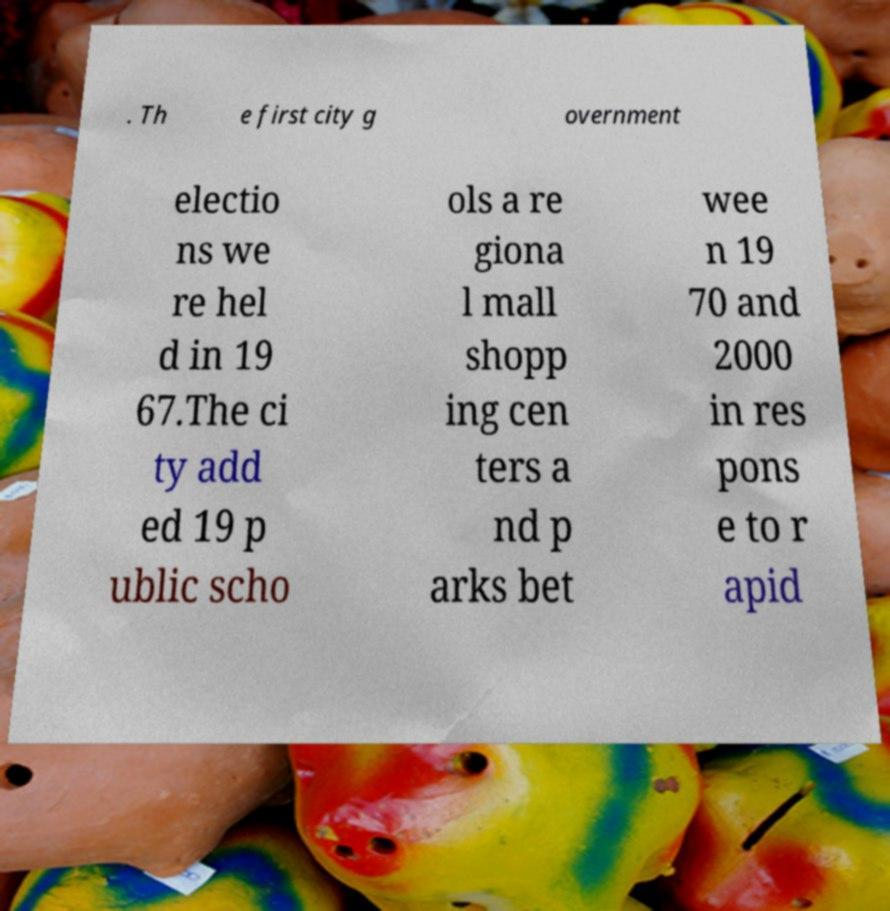For documentation purposes, I need the text within this image transcribed. Could you provide that? . Th e first city g overnment electio ns we re hel d in 19 67.The ci ty add ed 19 p ublic scho ols a re giona l mall shopp ing cen ters a nd p arks bet wee n 19 70 and 2000 in res pons e to r apid 